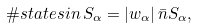<formula> <loc_0><loc_0><loc_500><loc_500>\# s t a t e s i n \, S _ { \alpha } = | w _ { \alpha } | \, \bar { n } S _ { \alpha } ,</formula> 